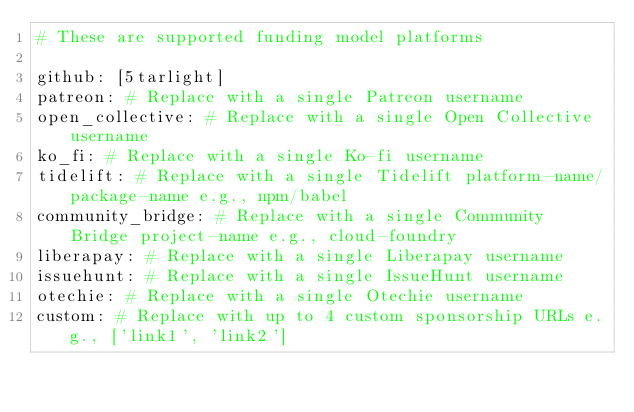<code> <loc_0><loc_0><loc_500><loc_500><_YAML_># These are supported funding model platforms

github: [5tarlight]
patreon: # Replace with a single Patreon username
open_collective: # Replace with a single Open Collective username
ko_fi: # Replace with a single Ko-fi username
tidelift: # Replace with a single Tidelift platform-name/package-name e.g., npm/babel
community_bridge: # Replace with a single Community Bridge project-name e.g., cloud-foundry
liberapay: # Replace with a single Liberapay username
issuehunt: # Replace with a single IssueHunt username
otechie: # Replace with a single Otechie username
custom: # Replace with up to 4 custom sponsorship URLs e.g., ['link1', 'link2']
</code> 